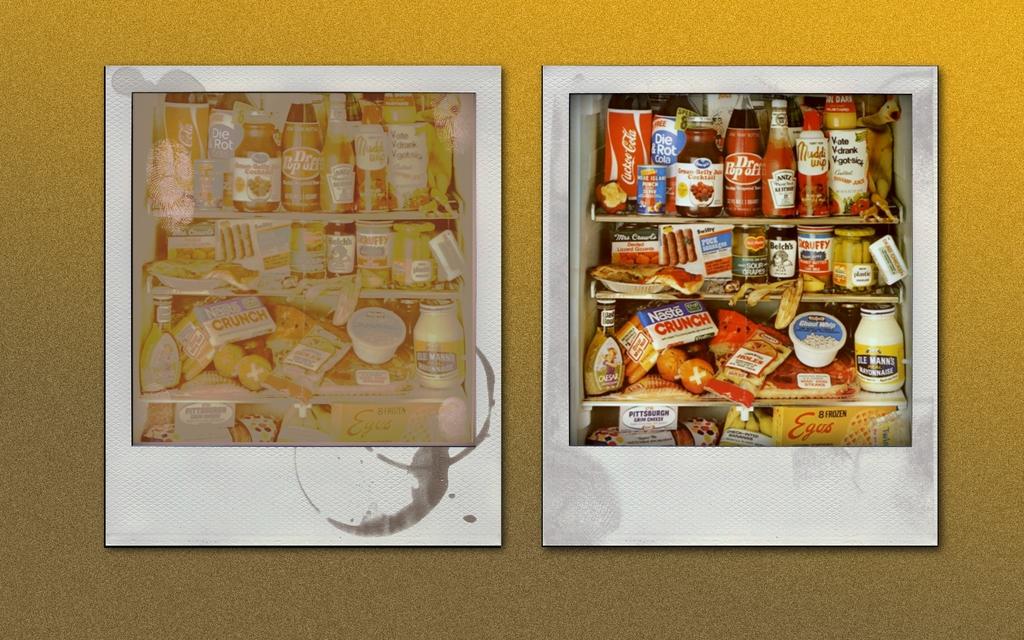What brand soda is on the top left shelf of the right image?
Offer a very short reply. Coca cola. 